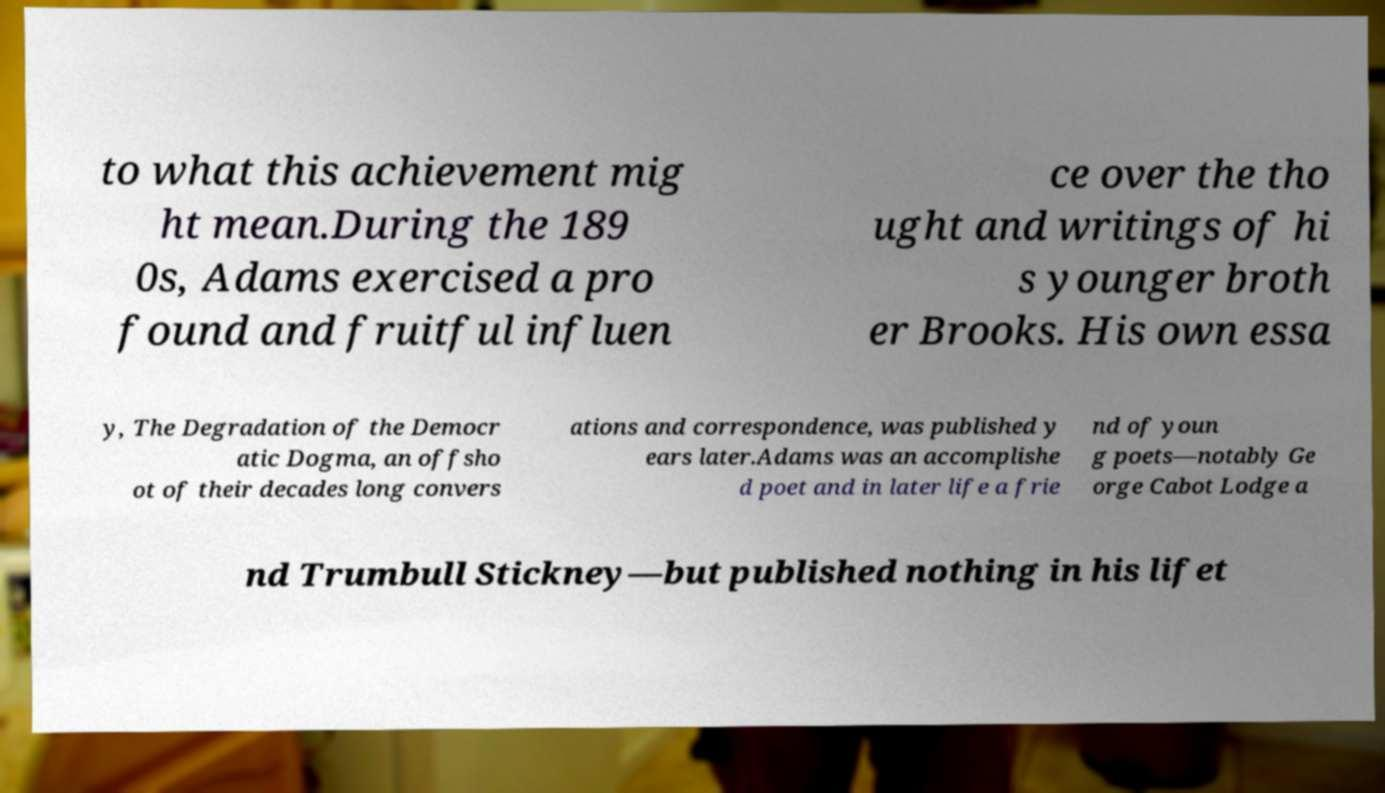Please identify and transcribe the text found in this image. to what this achievement mig ht mean.During the 189 0s, Adams exercised a pro found and fruitful influen ce over the tho ught and writings of hi s younger broth er Brooks. His own essa y, The Degradation of the Democr atic Dogma, an offsho ot of their decades long convers ations and correspondence, was published y ears later.Adams was an accomplishe d poet and in later life a frie nd of youn g poets—notably Ge orge Cabot Lodge a nd Trumbull Stickney—but published nothing in his lifet 